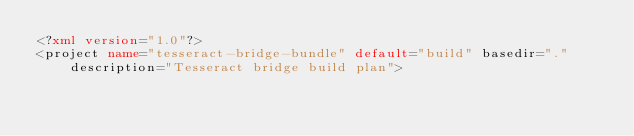Convert code to text. <code><loc_0><loc_0><loc_500><loc_500><_XML_><?xml version="1.0"?>
<project name="tesseract-bridge-bundle" default="build" basedir="." description="Tesseract bridge build plan"></code> 